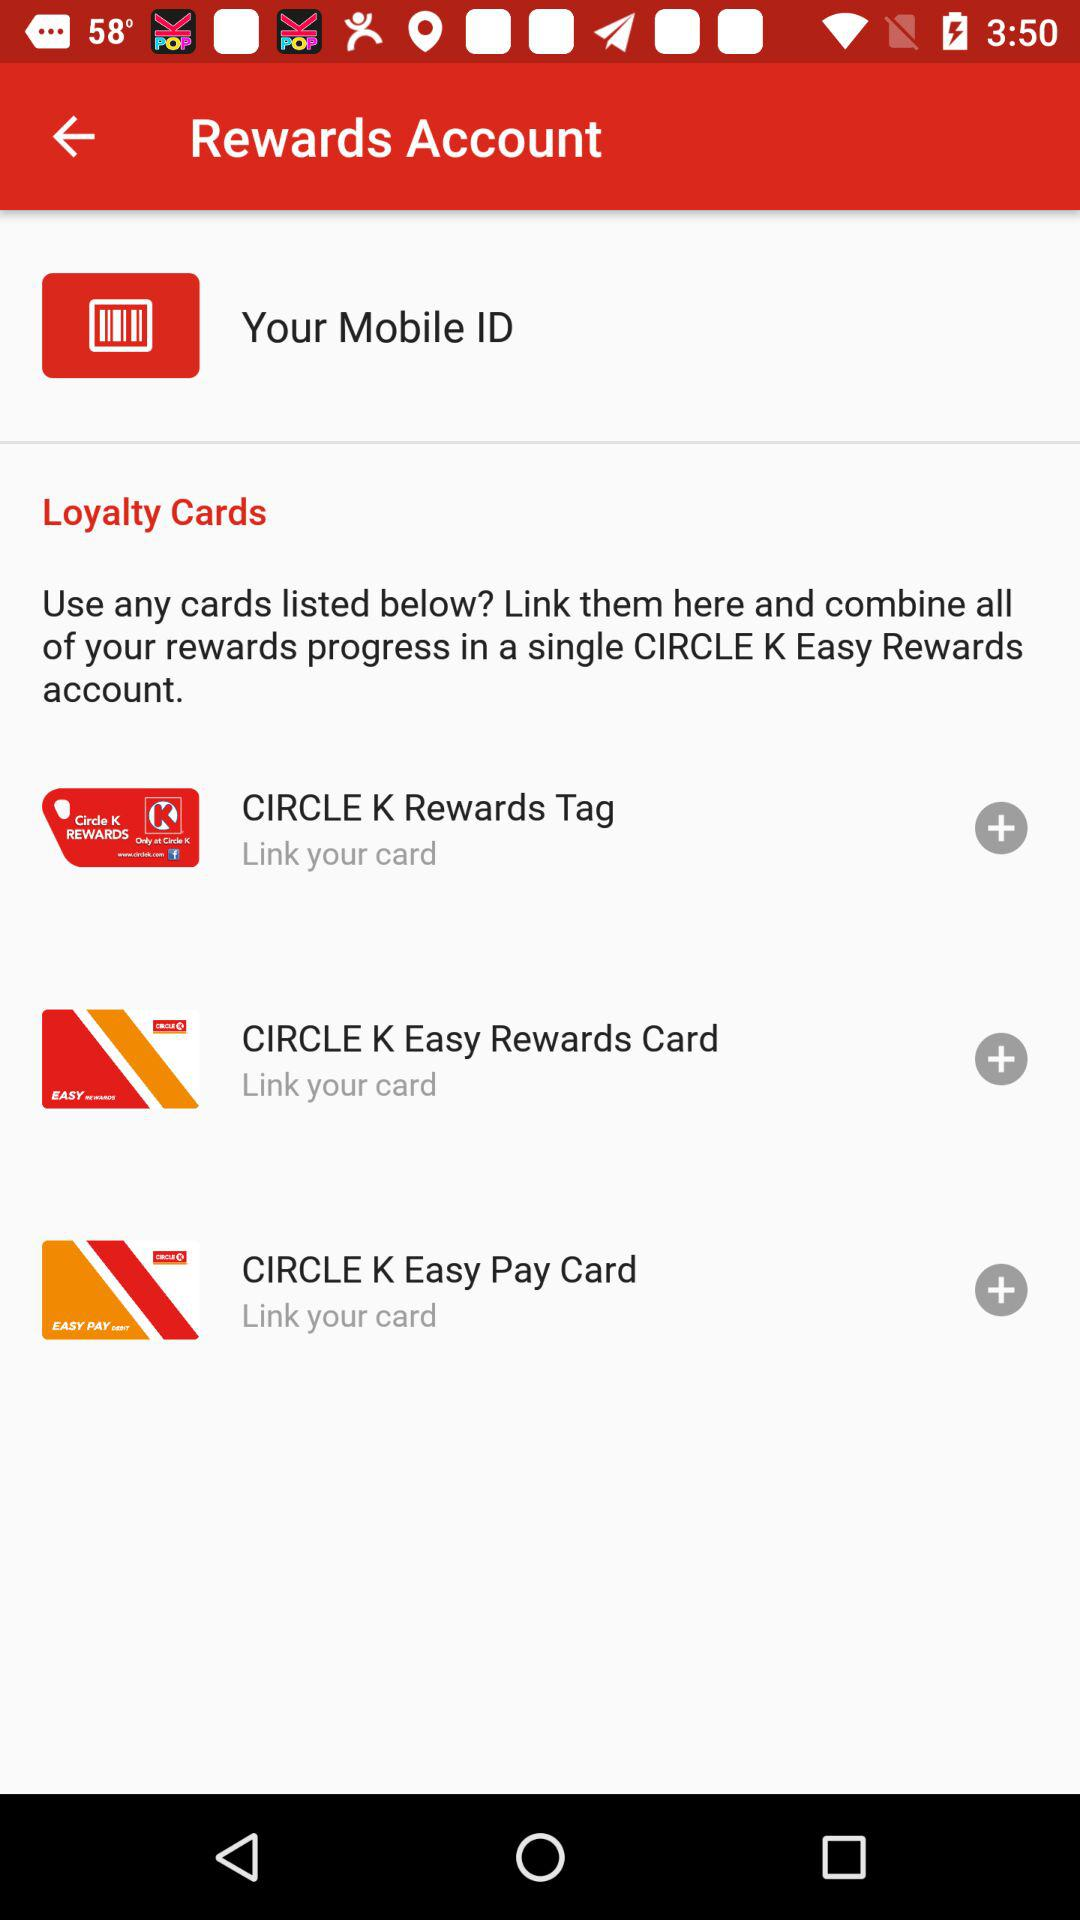How many loyalty cards can be linked to this account?
Answer the question using a single word or phrase. 3 